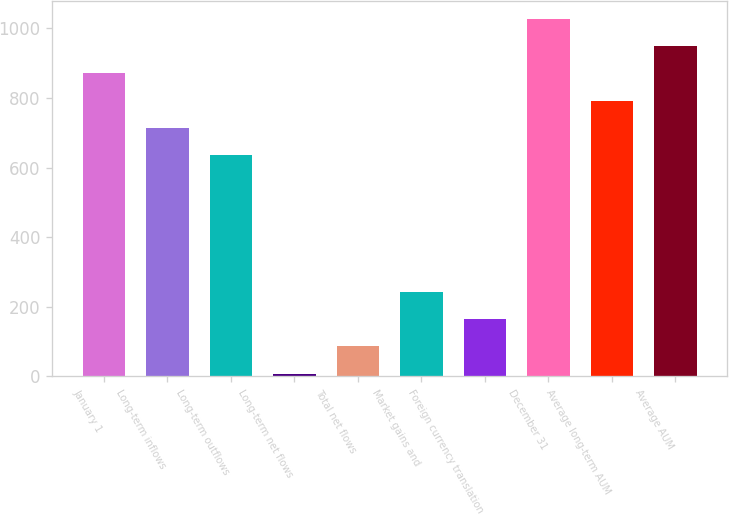Convert chart. <chart><loc_0><loc_0><loc_500><loc_500><bar_chart><fcel>January 1<fcel>Long-term inflows<fcel>Long-term outflows<fcel>Long-term net flows<fcel>Total net flows<fcel>Market gains and<fcel>Foreign currency translation<fcel>December 31<fcel>Average long-term AUM<fcel>Average AUM<nl><fcel>870.83<fcel>713.97<fcel>635.54<fcel>8.1<fcel>86.53<fcel>243.39<fcel>164.96<fcel>1027.69<fcel>792.4<fcel>949.26<nl></chart> 